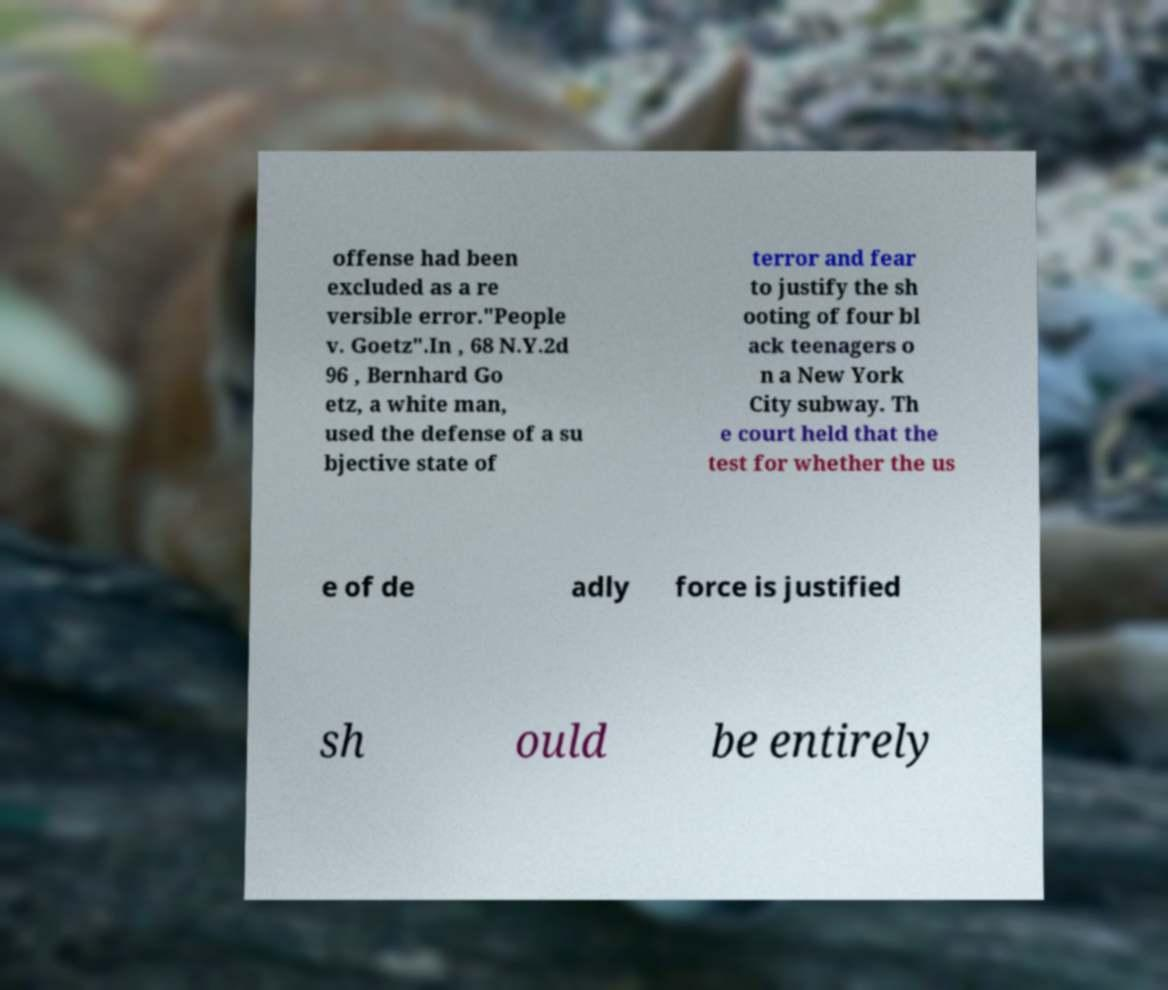For documentation purposes, I need the text within this image transcribed. Could you provide that? offense had been excluded as a re versible error."People v. Goetz".In , 68 N.Y.2d 96 , Bernhard Go etz, a white man, used the defense of a su bjective state of terror and fear to justify the sh ooting of four bl ack teenagers o n a New York City subway. Th e court held that the test for whether the us e of de adly force is justified sh ould be entirely 